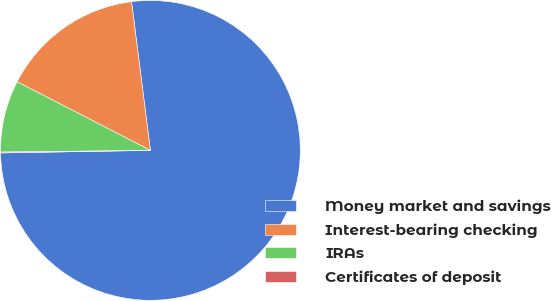Convert chart to OTSL. <chart><loc_0><loc_0><loc_500><loc_500><pie_chart><fcel>Money market and savings<fcel>Interest-bearing checking<fcel>IRAs<fcel>Certificates of deposit<nl><fcel>76.74%<fcel>15.42%<fcel>7.75%<fcel>0.09%<nl></chart> 